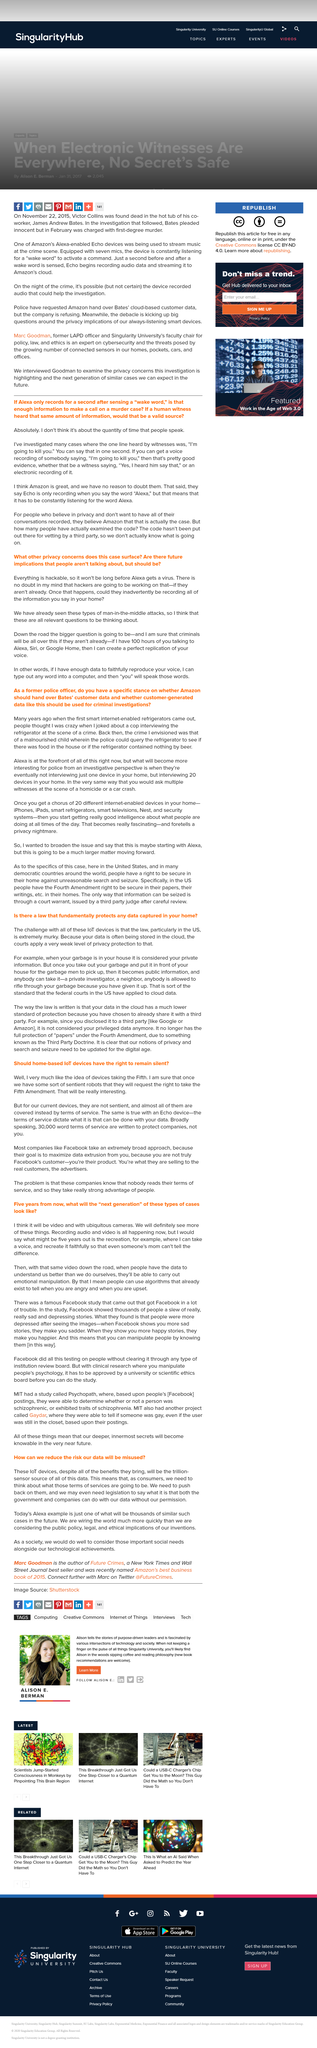Highlight a few significant elements in this photo. After sensing a "wake word," Alexa begins recording. The validity of a single second of information as a source is not determined by the quantity of time that people speak, but rather by the quality and reliability of the information provided. It is possible for a human to hear someone say "I'm going to kill you" in one second. 